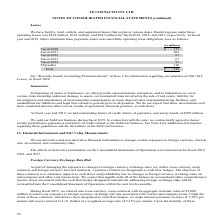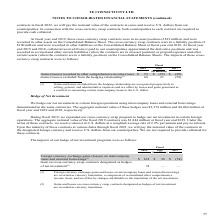According to Te Connectivity's financial document, How are Gains and losses excluded from the hedging relationship recognized? recognized prospectively in selling, general, and administrative expenses and are offset by losses and gains generated as a result of re-measuring certain intercompany loans to the U.S. dollar. The document states: "losses excluded from the hedging relationship are recognized prospectively in selling, general, and administrative expenses and are offset by losses a..." Also, What was the liability position of the cross-currency swap contracts?  According to the financial document, $100 million. The relevant text states: "ncy swap contracts were in a liability position of $100 million and were recorded in other liabilities on the Consolidated Balance Sheet at fiscal year end 2018. At..." Also, What are the components of the impacts of cross-currency swap contracts in the table? The document shows two values: Gains (losses) recorded in other comprehensive income (loss) and Gains (losses) excluded from the hedging relationship. From the document: "Gains (losses) recorded in other comprehensive income (loss) $ 53 $ (25) $ (20) Gains (losses) excluded from the hedging relationship (1) 66 21 (58)..." Additionally, In which year was the Gains excluded from the hedging relationship the largest? According to the financial document, 2019. The relevant text states: "2019 2018 2017..." Also, can you calculate: What was the change in Gains excluded from the hedging relationship in 2019 from 2018? Based on the calculation: 66-21, the result is 45 (in millions). This is based on the information: "osses) excluded from the hedging relationship (1) 66 21 (58) es) excluded from the hedging relationship (1) 66 21 (58)..." The key data points involved are: 21, 66. Also, can you calculate: What was the percentage change in Gains excluded from the hedging relationship in 2019 from 2018? To answer this question, I need to perform calculations using the financial data. The calculation is: (66-21)/21, which equals 214.29 (percentage). This is based on the information: "osses) excluded from the hedging relationship (1) 66 21 (58) es) excluded from the hedging relationship (1) 66 21 (58)..." The key data points involved are: 66. 